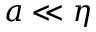Convert formula to latex. <formula><loc_0><loc_0><loc_500><loc_500>a \ll \eta</formula> 